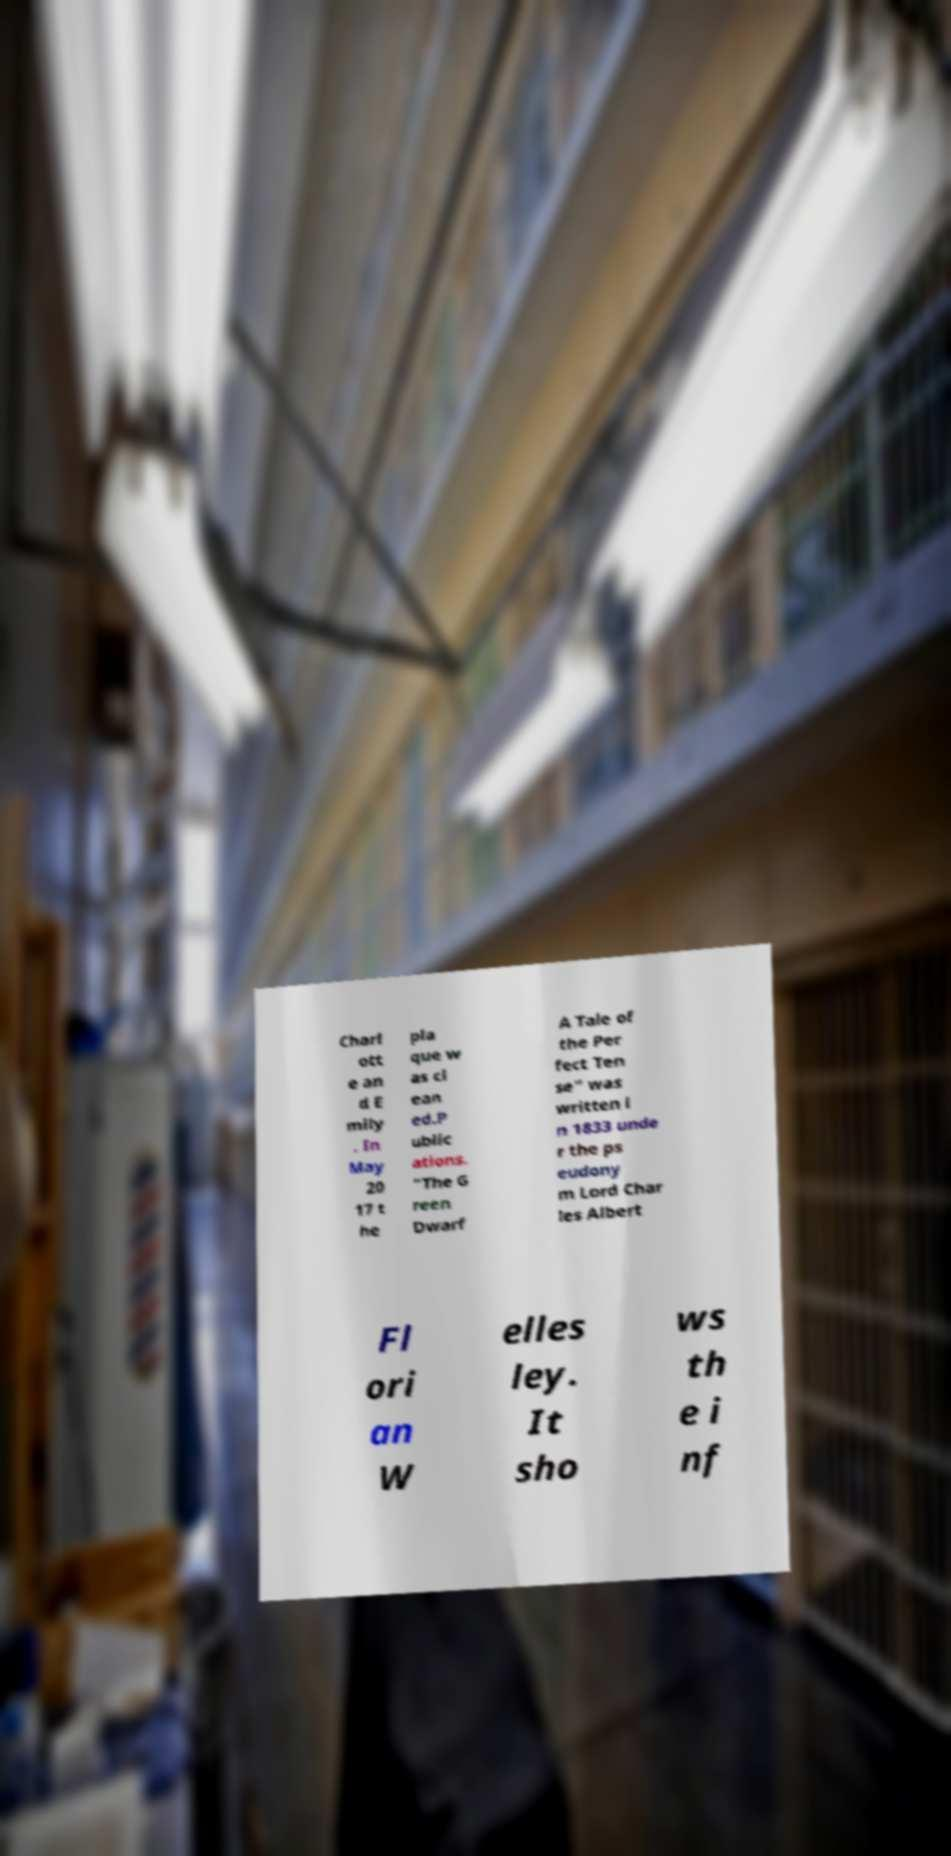Please read and relay the text visible in this image. What does it say? Charl ott e an d E mily . In May 20 17 t he pla que w as cl ean ed.P ublic ations. "The G reen Dwarf A Tale of the Per fect Ten se" was written i n 1833 unde r the ps eudony m Lord Char les Albert Fl ori an W elles ley. It sho ws th e i nf 